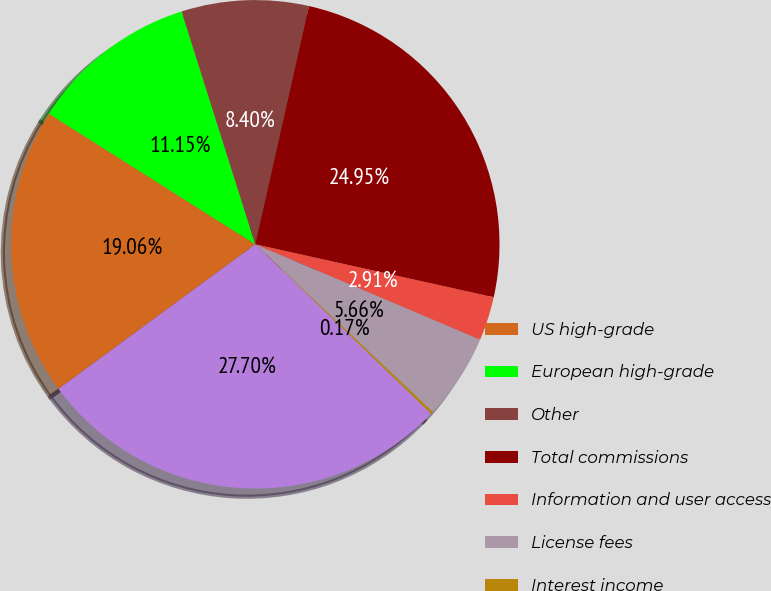<chart> <loc_0><loc_0><loc_500><loc_500><pie_chart><fcel>US high-grade<fcel>European high-grade<fcel>Other<fcel>Total commissions<fcel>Information and user access<fcel>License fees<fcel>Interest income<fcel>Total revenues<nl><fcel>19.06%<fcel>11.15%<fcel>8.4%<fcel>24.95%<fcel>2.91%<fcel>5.66%<fcel>0.17%<fcel>27.7%<nl></chart> 